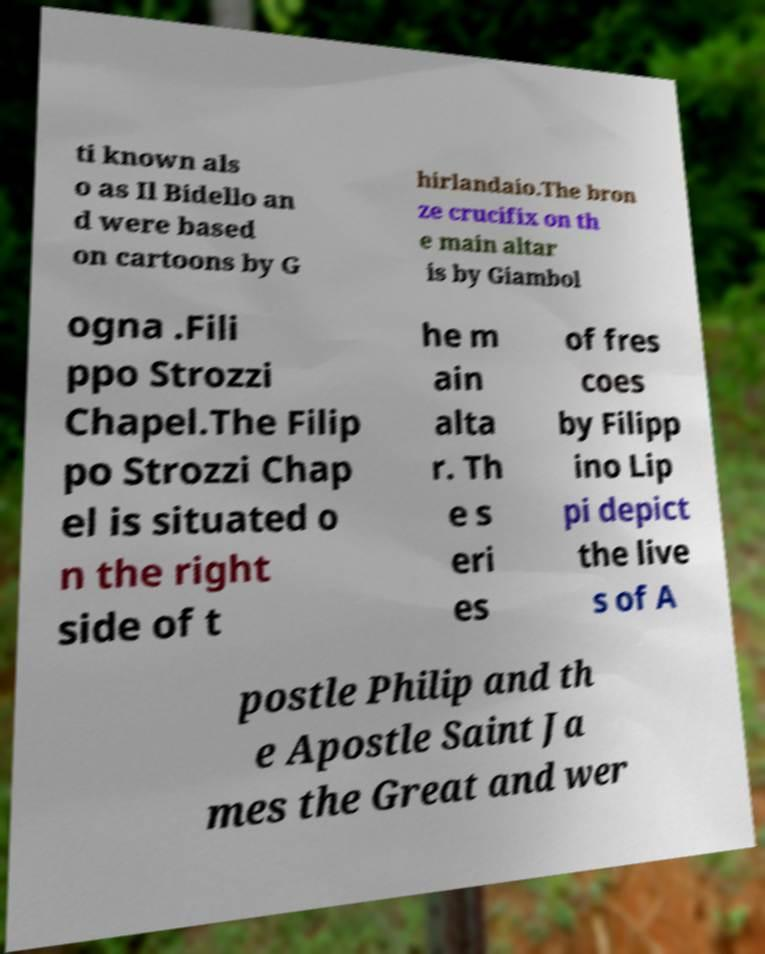What messages or text are displayed in this image? I need them in a readable, typed format. ti known als o as Il Bidello an d were based on cartoons by G hirlandaio.The bron ze crucifix on th e main altar is by Giambol ogna .Fili ppo Strozzi Chapel.The Filip po Strozzi Chap el is situated o n the right side of t he m ain alta r. Th e s eri es of fres coes by Filipp ino Lip pi depict the live s of A postle Philip and th e Apostle Saint Ja mes the Great and wer 